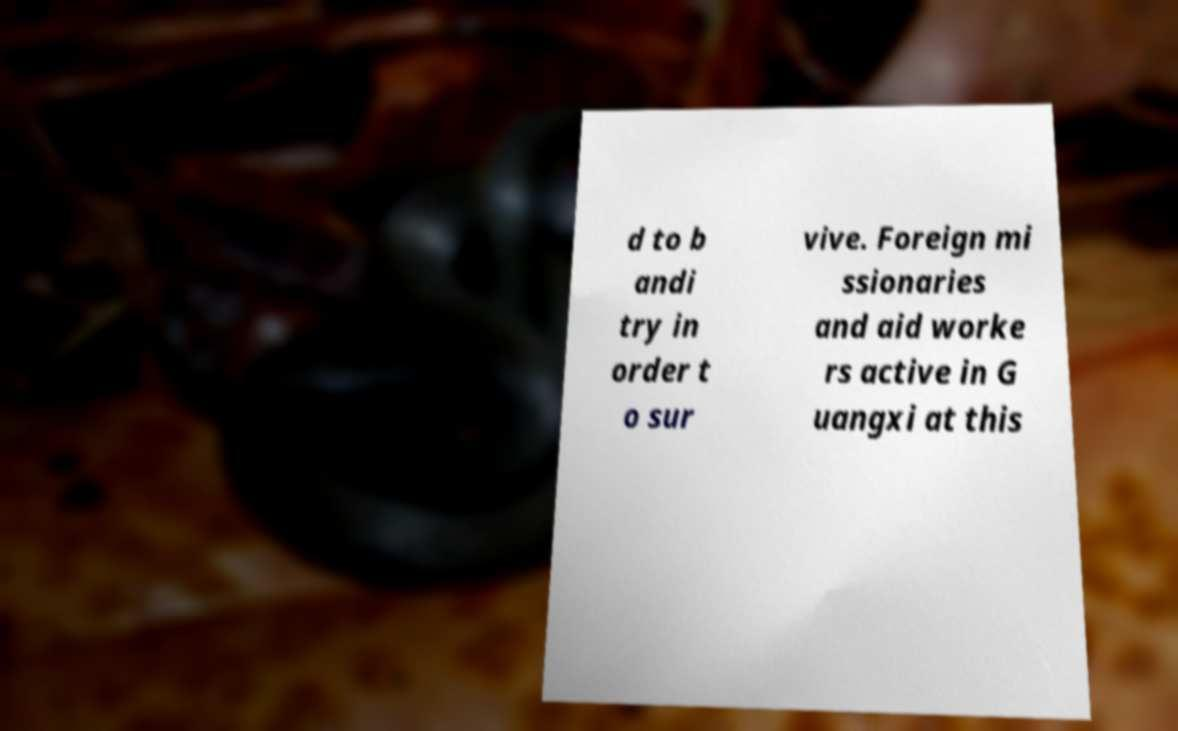There's text embedded in this image that I need extracted. Can you transcribe it verbatim? d to b andi try in order t o sur vive. Foreign mi ssionaries and aid worke rs active in G uangxi at this 